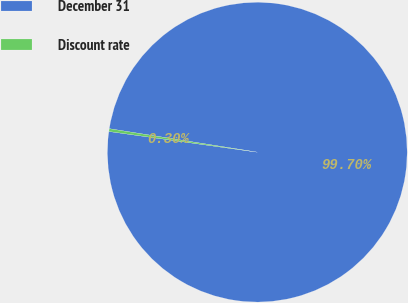Convert chart to OTSL. <chart><loc_0><loc_0><loc_500><loc_500><pie_chart><fcel>December 31<fcel>Discount rate<nl><fcel>99.7%<fcel>0.3%<nl></chart> 